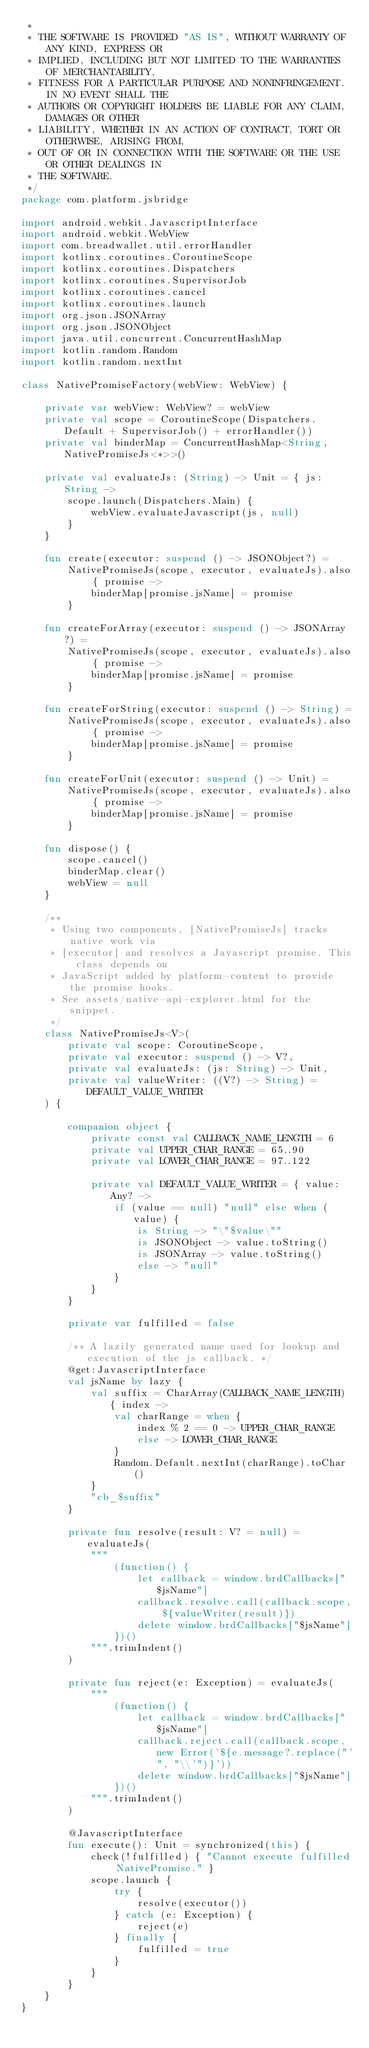<code> <loc_0><loc_0><loc_500><loc_500><_Kotlin_> *
 * THE SOFTWARE IS PROVIDED "AS IS", WITHOUT WARRANTY OF ANY KIND, EXPRESS OR
 * IMPLIED, INCLUDING BUT NOT LIMITED TO THE WARRANTIES OF MERCHANTABILITY,
 * FITNESS FOR A PARTICULAR PURPOSE AND NONINFRINGEMENT. IN NO EVENT SHALL THE
 * AUTHORS OR COPYRIGHT HOLDERS BE LIABLE FOR ANY CLAIM, DAMAGES OR OTHER
 * LIABILITY, WHETHER IN AN ACTION OF CONTRACT, TORT OR OTHERWISE, ARISING FROM,
 * OUT OF OR IN CONNECTION WITH THE SOFTWARE OR THE USE OR OTHER DEALINGS IN
 * THE SOFTWARE.
 */
package com.platform.jsbridge

import android.webkit.JavascriptInterface
import android.webkit.WebView
import com.breadwallet.util.errorHandler
import kotlinx.coroutines.CoroutineScope
import kotlinx.coroutines.Dispatchers
import kotlinx.coroutines.SupervisorJob
import kotlinx.coroutines.cancel
import kotlinx.coroutines.launch
import org.json.JSONArray
import org.json.JSONObject
import java.util.concurrent.ConcurrentHashMap
import kotlin.random.Random
import kotlin.random.nextInt

class NativePromiseFactory(webView: WebView) {

    private var webView: WebView? = webView
    private val scope = CoroutineScope(Dispatchers.Default + SupervisorJob() + errorHandler())
    private val binderMap = ConcurrentHashMap<String, NativePromiseJs<*>>()

    private val evaluateJs: (String) -> Unit = { js: String ->
        scope.launch(Dispatchers.Main) {
            webView.evaluateJavascript(js, null)
        }
    }

    fun create(executor: suspend () -> JSONObject?) =
        NativePromiseJs(scope, executor, evaluateJs).also { promise ->
            binderMap[promise.jsName] = promise
        }

    fun createForArray(executor: suspend () -> JSONArray?) =
        NativePromiseJs(scope, executor, evaluateJs).also { promise ->
            binderMap[promise.jsName] = promise
        }

    fun createForString(executor: suspend () -> String) =
        NativePromiseJs(scope, executor, evaluateJs).also { promise ->
            binderMap[promise.jsName] = promise
        }

    fun createForUnit(executor: suspend () -> Unit) =
        NativePromiseJs(scope, executor, evaluateJs).also { promise ->
            binderMap[promise.jsName] = promise
        }

    fun dispose() {
        scope.cancel()
        binderMap.clear()
        webView = null
    }

    /**
     * Using two components, [NativePromiseJs] tracks native work via
     * [executor] and resolves a Javascript promise. This class depends on
     * JavaScript added by platform-content to provide the promise hooks.
     * See assets/native-api-explorer.html for the snippet.
     */
    class NativePromiseJs<V>(
        private val scope: CoroutineScope,
        private val executor: suspend () -> V?,
        private val evaluateJs: (js: String) -> Unit,
        private val valueWriter: ((V?) -> String) = DEFAULT_VALUE_WRITER
    ) {

        companion object {
            private const val CALLBACK_NAME_LENGTH = 6
            private val UPPER_CHAR_RANGE = 65..90
            private val LOWER_CHAR_RANGE = 97..122

            private val DEFAULT_VALUE_WRITER = { value: Any? ->
                if (value == null) "null" else when (value) {
                    is String -> "\"$value\""
                    is JSONObject -> value.toString()
                    is JSONArray -> value.toString()
                    else -> "null"
                }
            }
        }

        private var fulfilled = false

        /** A lazily generated name used for lookup and execution of the js callback. */
        @get:JavascriptInterface
        val jsName by lazy {
            val suffix = CharArray(CALLBACK_NAME_LENGTH) { index ->
                val charRange = when {
                    index % 2 == 0 -> UPPER_CHAR_RANGE
                    else -> LOWER_CHAR_RANGE
                }
                Random.Default.nextInt(charRange).toChar()
            }
            "cb_$suffix"
        }

        private fun resolve(result: V? = null) = evaluateJs(
            """
                (function() {
                    let callback = window.brdCallbacks["$jsName"]
                    callback.resolve.call(callback.scope, ${valueWriter(result)})
                    delete window.brdCallbacks["$jsName"]
                })()
            """.trimIndent()
        )

        private fun reject(e: Exception) = evaluateJs(
            """
                (function() {
                    let callback = window.brdCallbacks["$jsName"]
                    callback.reject.call(callback.scope, new Error('${e.message?.replace("'", "\\'")}'))
                    delete window.brdCallbacks["$jsName"]
                })()
            """.trimIndent()
        )

        @JavascriptInterface
        fun execute(): Unit = synchronized(this) {
            check(!fulfilled) { "Cannot execute fulfilled NativePromise." }
            scope.launch {
                try {
                    resolve(executor())
                } catch (e: Exception) {
                    reject(e)
                } finally {
                    fulfilled = true
                }
            }
        }
    }
}
</code> 